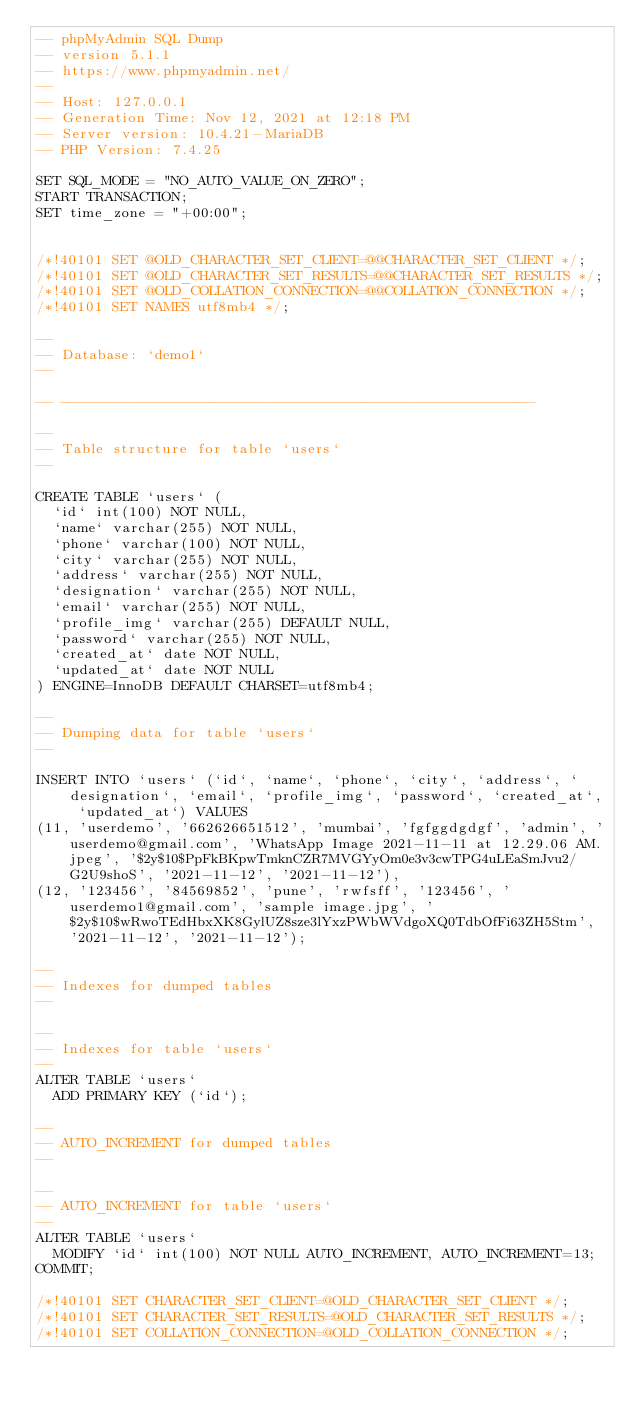Convert code to text. <code><loc_0><loc_0><loc_500><loc_500><_SQL_>-- phpMyAdmin SQL Dump
-- version 5.1.1
-- https://www.phpmyadmin.net/
--
-- Host: 127.0.0.1
-- Generation Time: Nov 12, 2021 at 12:18 PM
-- Server version: 10.4.21-MariaDB
-- PHP Version: 7.4.25

SET SQL_MODE = "NO_AUTO_VALUE_ON_ZERO";
START TRANSACTION;
SET time_zone = "+00:00";


/*!40101 SET @OLD_CHARACTER_SET_CLIENT=@@CHARACTER_SET_CLIENT */;
/*!40101 SET @OLD_CHARACTER_SET_RESULTS=@@CHARACTER_SET_RESULTS */;
/*!40101 SET @OLD_COLLATION_CONNECTION=@@COLLATION_CONNECTION */;
/*!40101 SET NAMES utf8mb4 */;

--
-- Database: `demo1`
--

-- --------------------------------------------------------

--
-- Table structure for table `users`
--

CREATE TABLE `users` (
  `id` int(100) NOT NULL,
  `name` varchar(255) NOT NULL,
  `phone` varchar(100) NOT NULL,
  `city` varchar(255) NOT NULL,
  `address` varchar(255) NOT NULL,
  `designation` varchar(255) NOT NULL,
  `email` varchar(255) NOT NULL,
  `profile_img` varchar(255) DEFAULT NULL,
  `password` varchar(255) NOT NULL,
  `created_at` date NOT NULL,
  `updated_at` date NOT NULL
) ENGINE=InnoDB DEFAULT CHARSET=utf8mb4;

--
-- Dumping data for table `users`
--

INSERT INTO `users` (`id`, `name`, `phone`, `city`, `address`, `designation`, `email`, `profile_img`, `password`, `created_at`, `updated_at`) VALUES
(11, 'userdemo', '662626651512', 'mumbai', 'fgfggdgdgf', 'admin', 'userdemo@gmail.com', 'WhatsApp Image 2021-11-11 at 12.29.06 AM.jpeg', '$2y$10$PpFkBKpwTmknCZR7MVGYyOm0e3v3cwTPG4uLEaSmJvu2/G2U9shoS', '2021-11-12', '2021-11-12'),
(12, '123456', '84569852', 'pune', 'rwfsff', '123456', 'userdemo1@gmail.com', 'sample image.jpg', '$2y$10$wRwoTEdHbxXK8GylUZ8sze3lYxzPWbWVdgoXQ0TdbOfFi63ZH5Stm', '2021-11-12', '2021-11-12');

--
-- Indexes for dumped tables
--

--
-- Indexes for table `users`
--
ALTER TABLE `users`
  ADD PRIMARY KEY (`id`);

--
-- AUTO_INCREMENT for dumped tables
--

--
-- AUTO_INCREMENT for table `users`
--
ALTER TABLE `users`
  MODIFY `id` int(100) NOT NULL AUTO_INCREMENT, AUTO_INCREMENT=13;
COMMIT;

/*!40101 SET CHARACTER_SET_CLIENT=@OLD_CHARACTER_SET_CLIENT */;
/*!40101 SET CHARACTER_SET_RESULTS=@OLD_CHARACTER_SET_RESULTS */;
/*!40101 SET COLLATION_CONNECTION=@OLD_COLLATION_CONNECTION */;
</code> 